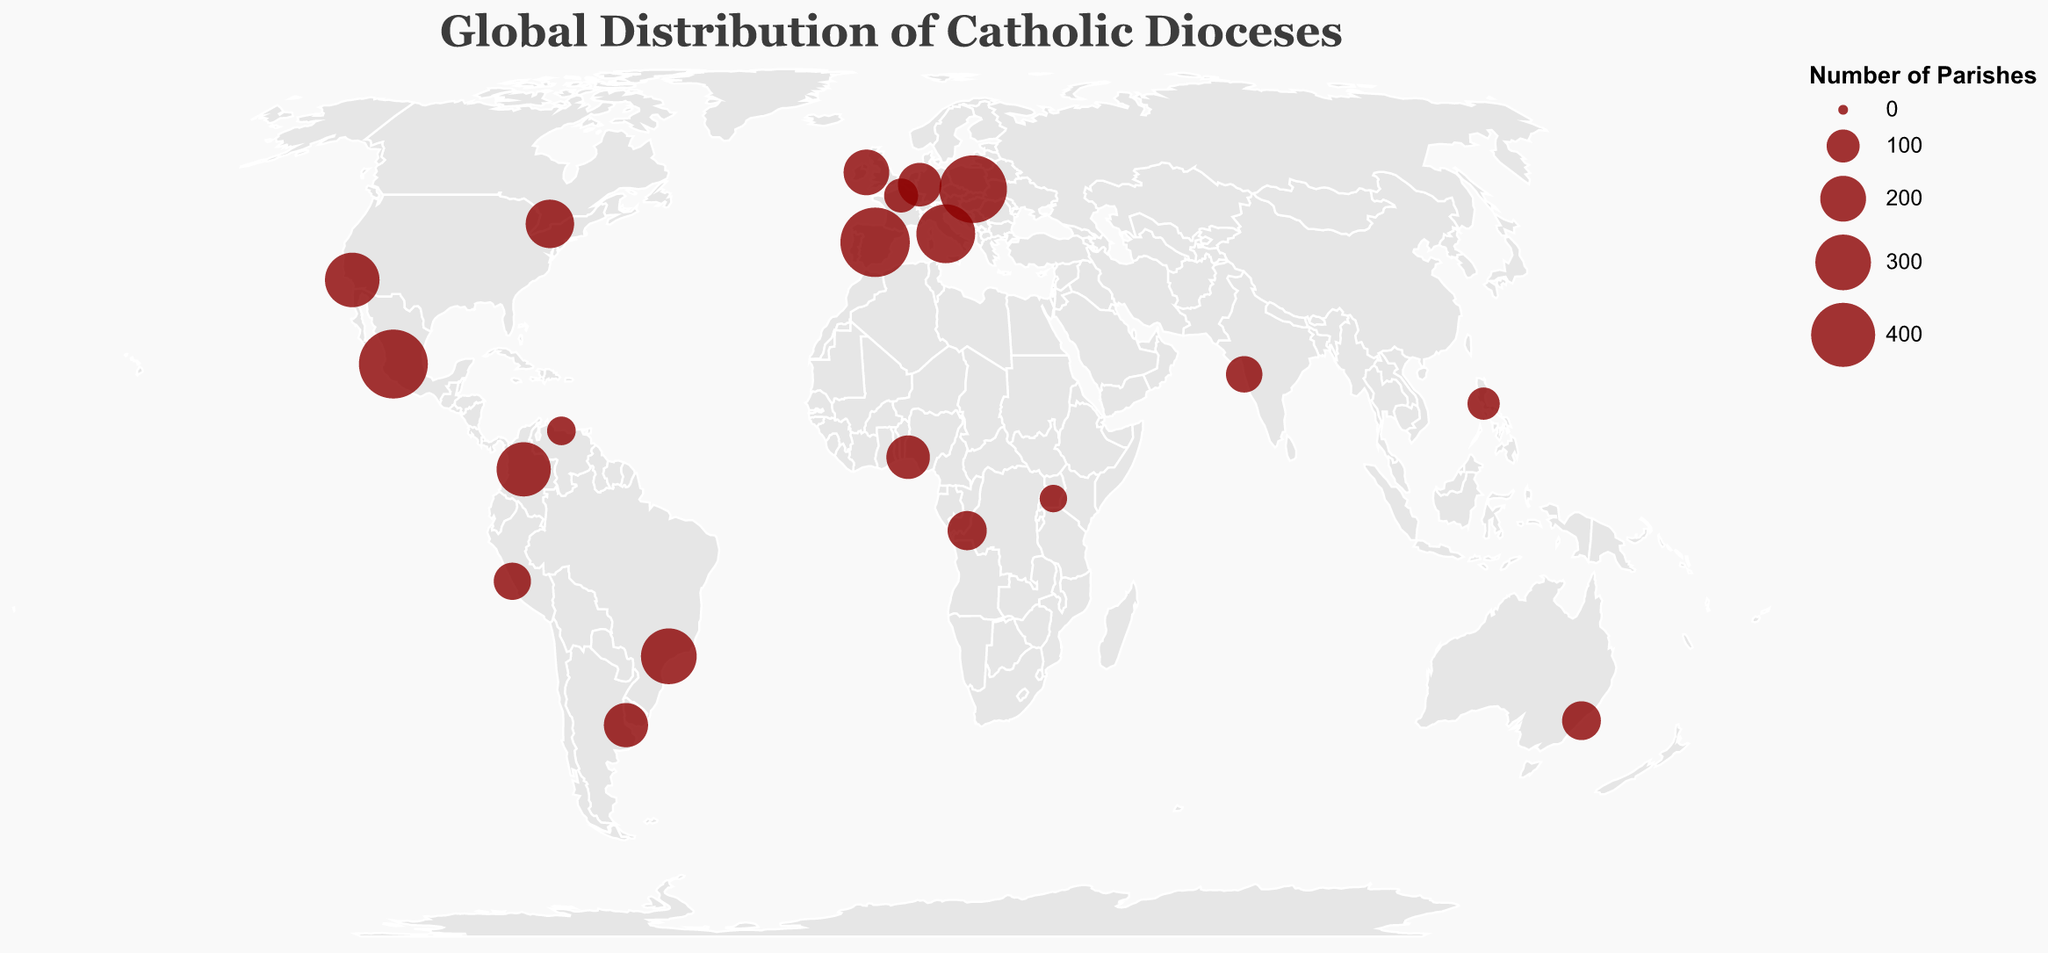What is the title of this figure? The title is located at the top of the figure, often indicating its content and main emphasis. In this case, it reads "Global Distribution of Catholic Dioceses".
Answer: Global Distribution of Catholic Dioceses Which diocese has the highest number of parishes? By examining the figure, focusing on the size of the circles which indicate the number of parishes, and referring to the tooltip information, we see that Madrid (Spain) has the largest circle, with 472 parishes.
Answer: Madrid (Spain) Which diocese has the lowest number of parishes depicted in the figure? By looking at the smallest circles and checking the tooltip for confirmation, Kampala in Uganda has the smallest circle with 66 parishes.
Answer: Kampala (Uganda) How many dioceses have more than 300 parishes? By scanning the figure and identifying the circles with larger sizes, we observe and count the dioceses with tooltip information showing more than 300 parishes. They are Rome, São Paulo, Guadalajara, and Kraków. There are 4 dioceses meeting this criterion.
Answer: 4 What is the total number of parishes in the dioceses of Kraków and Guadalajara combined? From the visual information, Kraków has 447 parishes and Guadalajara has 465 parishes. Adding these gives 447 + 465 = 912 parishes.
Answer: 912 Which country has the most dioceses represented on the map? Reviewing the countries mentioned in the tooltip for the circles, each one represents a single diocese in the figure, so no country has more than one diocese represented.
Answer: Each country has 1 diocese represented How does the number of parishes in Manila compare to that in Bogotá? Referring to the tooltip information, Manila in the Philippines has 95 parishes while Bogotá in Colombia has 284 parishes. Bogotá has significantly more parishes than Manila.
Answer: Bogotá has more Which diocese closest to the equator has the most parishes? Checking the latitude values in the figure, Kampala, Kinshasa, and Bogotá are close to the equator. Among these, Bogotá has the most parishes (284).
Answer: Bogotá What is the average number of parishes among the dioceses in France, Germany, and Ireland? Paris has 106 parishes, Cologne has 180 parishes, and Dublin has 199 parishes. The average is calculated as (106 + 180 + 199) / 3 = 161.67.
Answer: 161.67 Which continent has the highest number of parishes when summing up all represented dioceses? Extracting the continent-wise data: Europe (Rome: 336, Kraków: 447, Madrid: 472, Paris: 106, Cologne: 180, Dublin: 199) with a sum of 1740 parishes. Summing these values shows Europe has the highest number of parishes.
Answer: Europe 